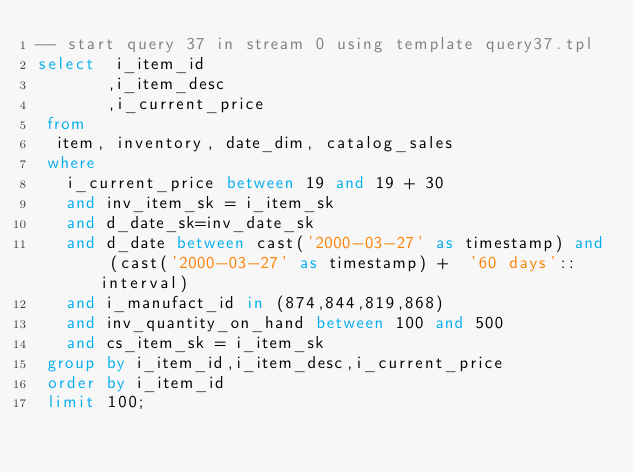<code> <loc_0><loc_0><loc_500><loc_500><_SQL_>-- start query 37 in stream 0 using template query37.tpl
select  i_item_id
       ,i_item_desc
       ,i_current_price
 from 
 	item, inventory, date_dim, catalog_sales
 where 
	 i_current_price between 19 and 19 + 30
	 and inv_item_sk = i_item_sk
	 and d_date_sk=inv_date_sk
	 and d_date between cast('2000-03-27' as timestamp) and (cast('2000-03-27' as timestamp) +  '60 days'::interval) 
	 and i_manufact_id in (874,844,819,868)
	 and inv_quantity_on_hand between 100 and 500
	 and cs_item_sk = i_item_sk
 group by i_item_id,i_item_desc,i_current_price
 order by i_item_id
 limit 100;
</code> 